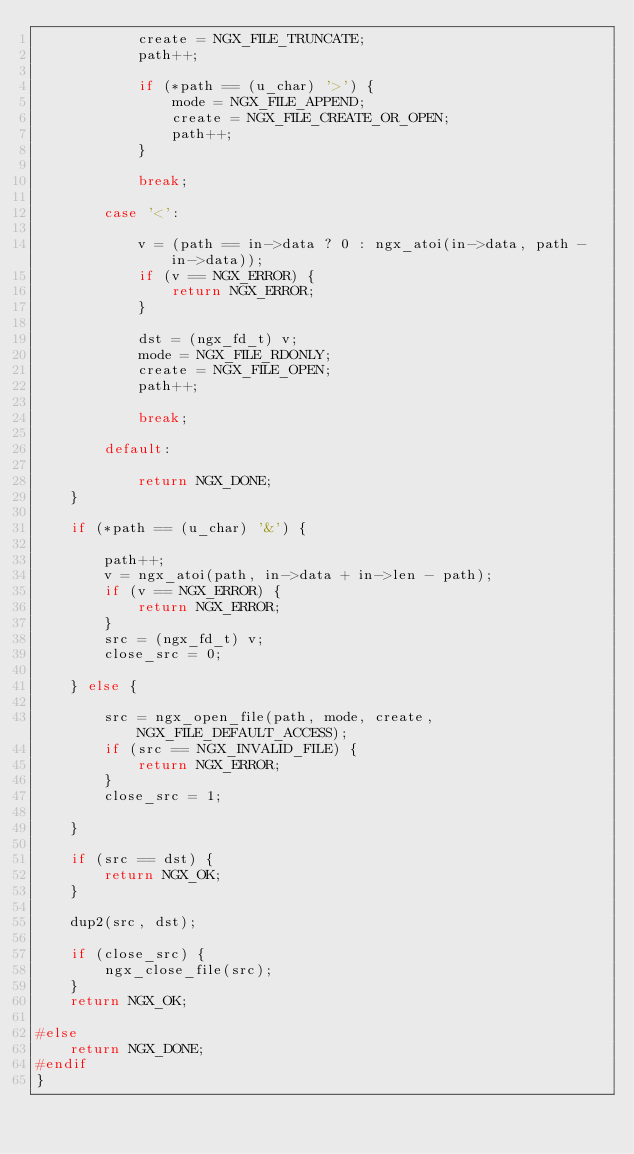Convert code to text. <code><loc_0><loc_0><loc_500><loc_500><_C_>            create = NGX_FILE_TRUNCATE;
            path++;

            if (*path == (u_char) '>') {
                mode = NGX_FILE_APPEND;
                create = NGX_FILE_CREATE_OR_OPEN;
                path++;
            }

            break;

        case '<':

            v = (path == in->data ? 0 : ngx_atoi(in->data, path - in->data));
            if (v == NGX_ERROR) {
                return NGX_ERROR;
            }

            dst = (ngx_fd_t) v;
            mode = NGX_FILE_RDONLY;
            create = NGX_FILE_OPEN;
            path++;

            break;

        default:

            return NGX_DONE;
    }

    if (*path == (u_char) '&') {

        path++;
        v = ngx_atoi(path, in->data + in->len - path);
        if (v == NGX_ERROR) {
            return NGX_ERROR;
        }
        src = (ngx_fd_t) v;
        close_src = 0;

    } else {

        src = ngx_open_file(path, mode, create, NGX_FILE_DEFAULT_ACCESS);
        if (src == NGX_INVALID_FILE) {
            return NGX_ERROR;
        }
        close_src = 1;

    }

    if (src == dst) {
        return NGX_OK;
    }

    dup2(src, dst);

    if (close_src) {
        ngx_close_file(src);
    }
    return NGX_OK;

#else
    return NGX_DONE;
#endif
}
</code> 